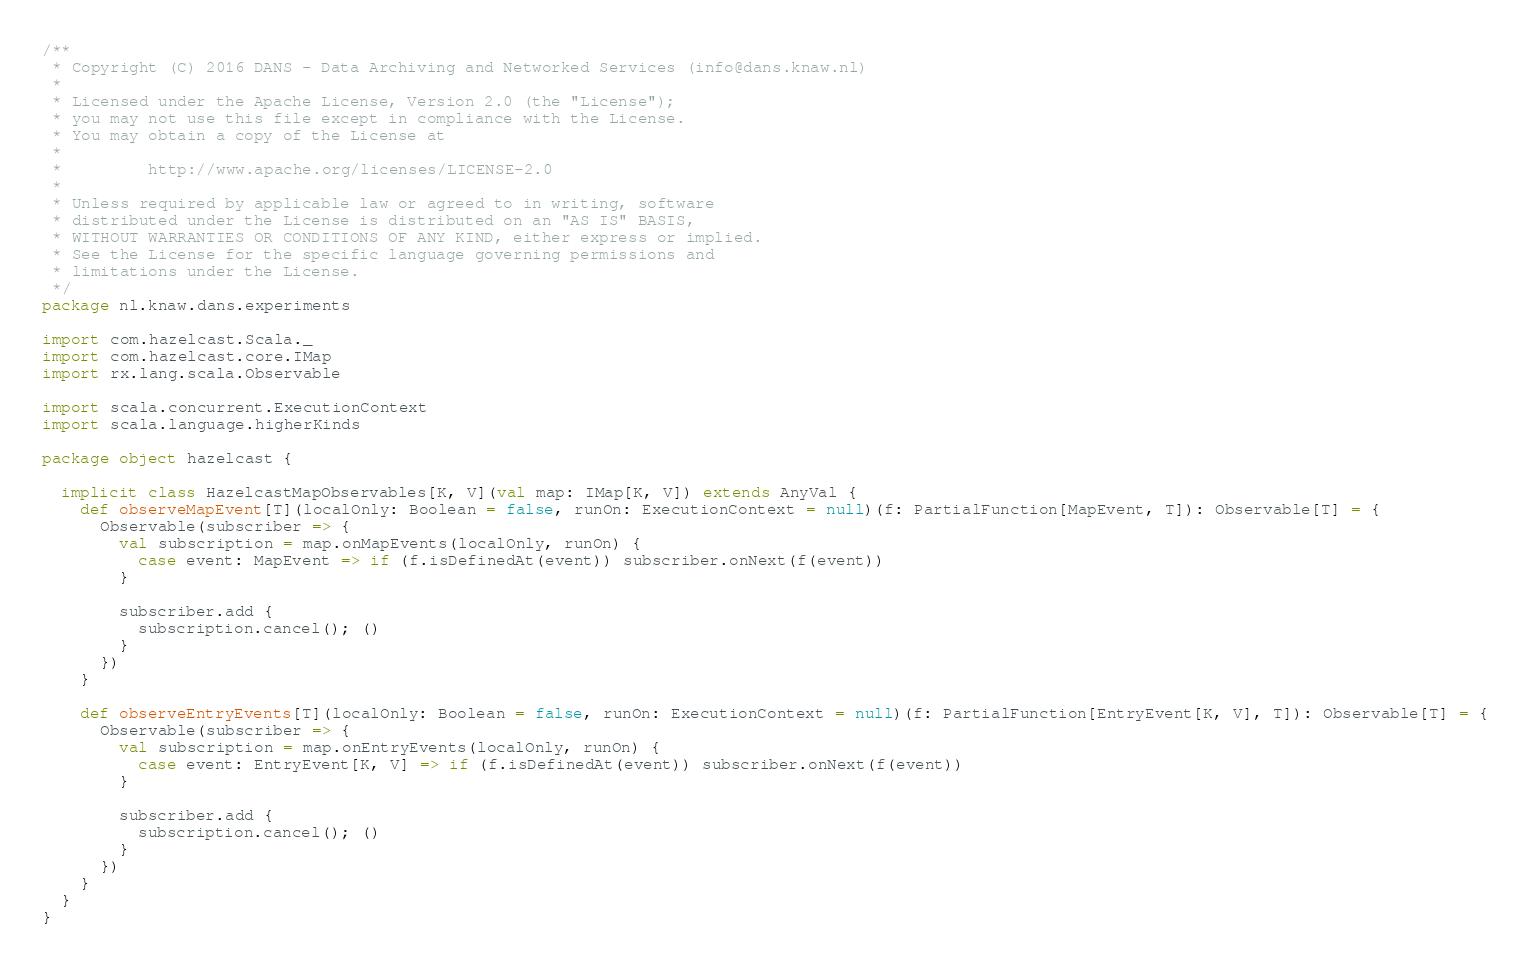Convert code to text. <code><loc_0><loc_0><loc_500><loc_500><_Scala_>/**
 * Copyright (C) 2016 DANS - Data Archiving and Networked Services (info@dans.knaw.nl)
 *
 * Licensed under the Apache License, Version 2.0 (the "License");
 * you may not use this file except in compliance with the License.
 * You may obtain a copy of the License at
 *
 *         http://www.apache.org/licenses/LICENSE-2.0
 *
 * Unless required by applicable law or agreed to in writing, software
 * distributed under the License is distributed on an "AS IS" BASIS,
 * WITHOUT WARRANTIES OR CONDITIONS OF ANY KIND, either express or implied.
 * See the License for the specific language governing permissions and
 * limitations under the License.
 */
package nl.knaw.dans.experiments

import com.hazelcast.Scala._
import com.hazelcast.core.IMap
import rx.lang.scala.Observable

import scala.concurrent.ExecutionContext
import scala.language.higherKinds

package object hazelcast {

  implicit class HazelcastMapObservables[K, V](val map: IMap[K, V]) extends AnyVal {
    def observeMapEvent[T](localOnly: Boolean = false, runOn: ExecutionContext = null)(f: PartialFunction[MapEvent, T]): Observable[T] = {
      Observable(subscriber => {
        val subscription = map.onMapEvents(localOnly, runOn) {
          case event: MapEvent => if (f.isDefinedAt(event)) subscriber.onNext(f(event))
        }

        subscriber.add {
          subscription.cancel(); ()
        }
      })
    }

    def observeEntryEvents[T](localOnly: Boolean = false, runOn: ExecutionContext = null)(f: PartialFunction[EntryEvent[K, V], T]): Observable[T] = {
      Observable(subscriber => {
        val subscription = map.onEntryEvents(localOnly, runOn) {
          case event: EntryEvent[K, V] => if (f.isDefinedAt(event)) subscriber.onNext(f(event))
        }

        subscriber.add {
          subscription.cancel(); ()
        }
      })
    }
  }
}
</code> 